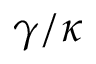Convert formula to latex. <formula><loc_0><loc_0><loc_500><loc_500>\gamma / \kappa</formula> 